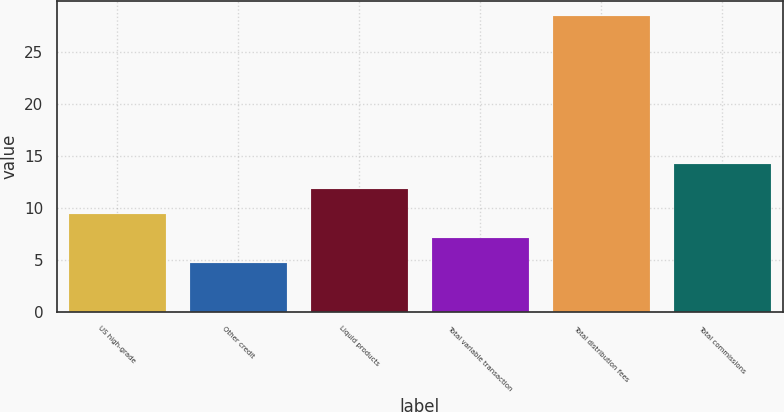Convert chart. <chart><loc_0><loc_0><loc_500><loc_500><bar_chart><fcel>US high-grade<fcel>Other credit<fcel>Liquid products<fcel>Total variable transaction<fcel>Total distribution fees<fcel>Total commissions<nl><fcel>9.44<fcel>4.7<fcel>11.81<fcel>7.07<fcel>28.4<fcel>14.18<nl></chart> 